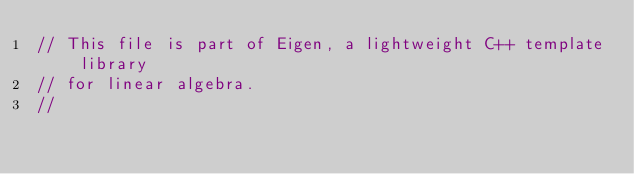Convert code to text. <code><loc_0><loc_0><loc_500><loc_500><_C_>// This file is part of Eigen, a lightweight C++ template library
// for linear algebra.
//</code> 